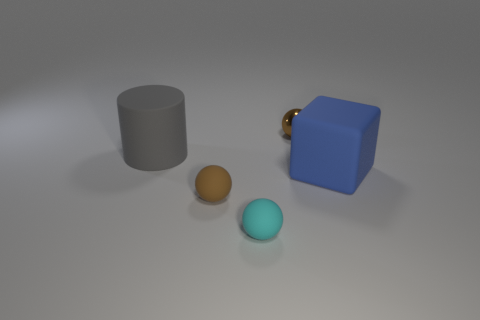Do the brown matte ball and the matte object that is on the right side of the brown metal ball have the same size?
Your answer should be very brief. No. Are there any metallic things that have the same color as the block?
Provide a succinct answer. No. Is there another rubber object of the same shape as the gray thing?
Make the answer very short. No. There is a matte object that is both to the right of the brown matte ball and in front of the big blue block; what is its shape?
Offer a very short reply. Sphere. What number of gray balls have the same material as the gray cylinder?
Your answer should be compact. 0. Are there fewer gray cylinders that are on the right side of the matte cylinder than blue objects?
Ensure brevity in your answer.  Yes. Are there any small brown rubber spheres in front of the small cyan thing in front of the small metallic object?
Provide a succinct answer. No. Are there any other things that are the same shape as the brown rubber thing?
Provide a succinct answer. Yes. Is the size of the rubber cylinder the same as the brown matte sphere?
Provide a short and direct response. No. What material is the big object that is to the left of the brown sphere in front of the tiny object behind the brown rubber thing?
Keep it short and to the point. Rubber. 